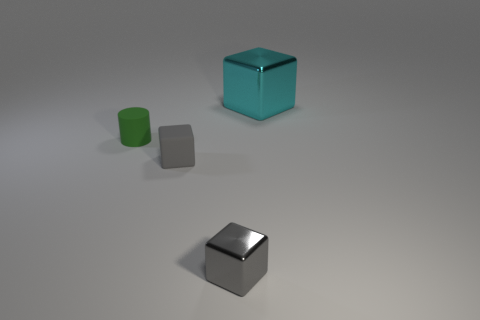There is a thing that is on the right side of the gray matte cube and in front of the green cylinder; what color is it?
Provide a succinct answer. Gray. There is a matte object to the right of the small green cylinder; does it have the same shape as the thing behind the cylinder?
Your answer should be very brief. Yes. There is a cyan thing behind the tiny green matte cylinder; what is it made of?
Ensure brevity in your answer.  Metal. The object that is the same color as the tiny matte cube is what size?
Provide a short and direct response. Small. What number of objects are either metallic things to the left of the big shiny block or small matte cylinders?
Your response must be concise. 2. Are there an equal number of blocks on the left side of the gray metallic thing and rubber things?
Ensure brevity in your answer.  No. Does the rubber cylinder have the same size as the gray rubber thing?
Your answer should be very brief. Yes. What is the color of the other matte thing that is the same size as the green thing?
Make the answer very short. Gray. Does the green cylinder have the same size as the metal thing in front of the tiny green matte thing?
Ensure brevity in your answer.  Yes. What number of large objects have the same color as the small cylinder?
Your answer should be compact. 0. 